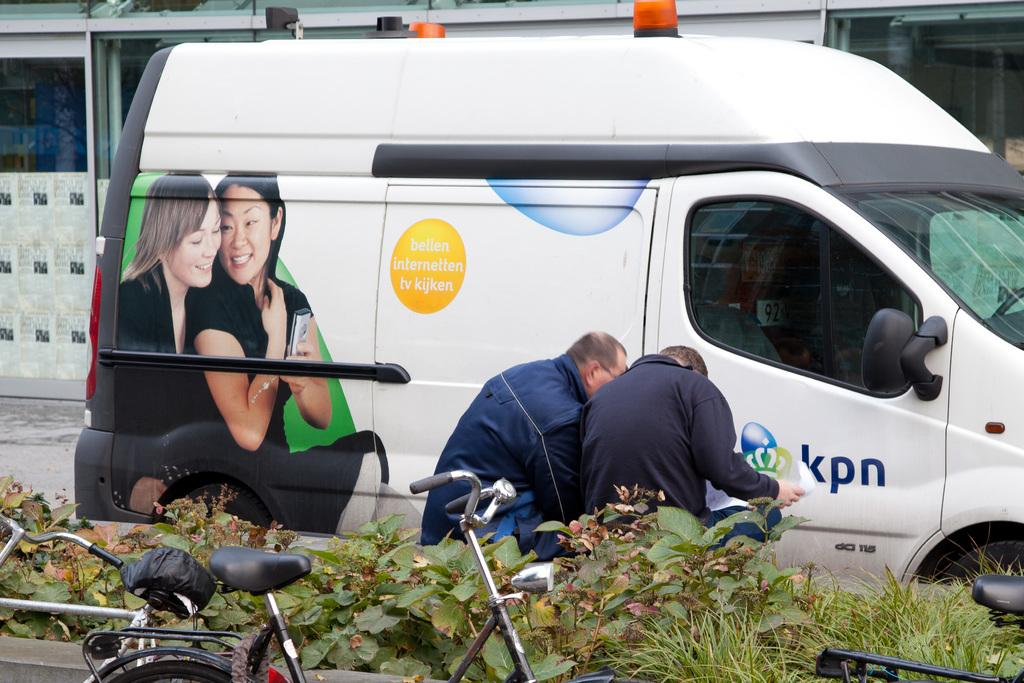<image>
Summarize the visual content of the image. Two men are bent over looking at some papers by a KPN van. 